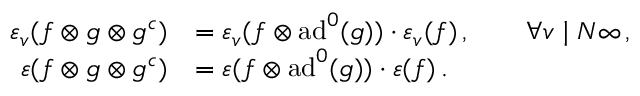<formula> <loc_0><loc_0><loc_500><loc_500>\begin{array} { r } { \begin{array} { r l } { \varepsilon _ { v } ( f \otimes g \otimes g ^ { c } ) } & { = \varepsilon _ { v } ( f \otimes a d ^ { 0 } ( g ) ) \cdot \varepsilon _ { v } ( f ) \, , \quad \forall v | N \infty \, , } \\ { \varepsilon ( f \otimes g \otimes g ^ { c } ) } & { = \varepsilon ( f \otimes a d ^ { 0 } ( g ) ) \cdot \varepsilon ( f ) \, . } \end{array} } \end{array}</formula> 